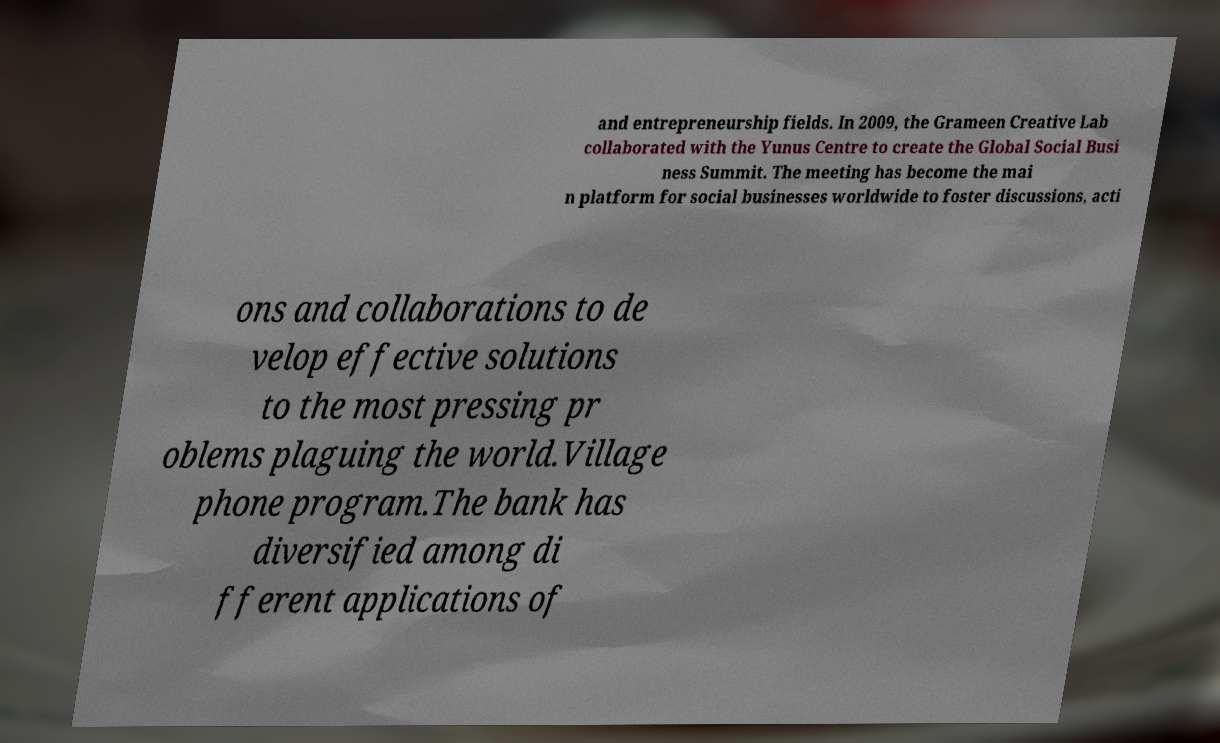Please read and relay the text visible in this image. What does it say? and entrepreneurship fields. In 2009, the Grameen Creative Lab collaborated with the Yunus Centre to create the Global Social Busi ness Summit. The meeting has become the mai n platform for social businesses worldwide to foster discussions, acti ons and collaborations to de velop effective solutions to the most pressing pr oblems plaguing the world.Village phone program.The bank has diversified among di fferent applications of 